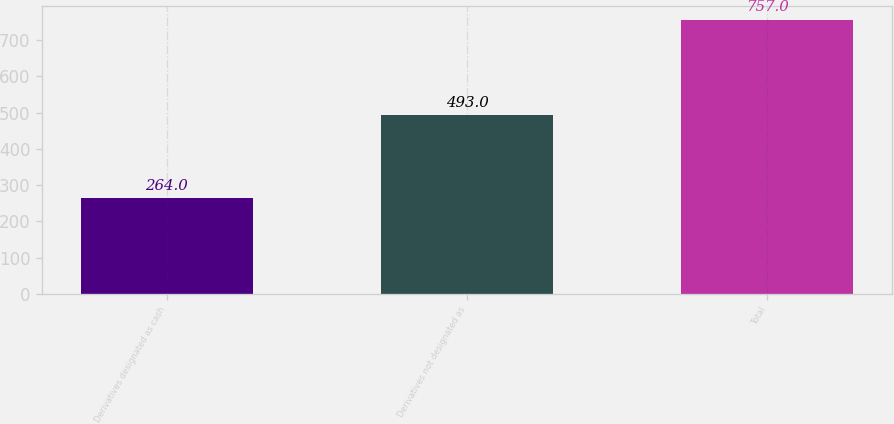Convert chart to OTSL. <chart><loc_0><loc_0><loc_500><loc_500><bar_chart><fcel>Derivatives designated as cash<fcel>Derivatives not designated as<fcel>Total<nl><fcel>264<fcel>493<fcel>757<nl></chart> 